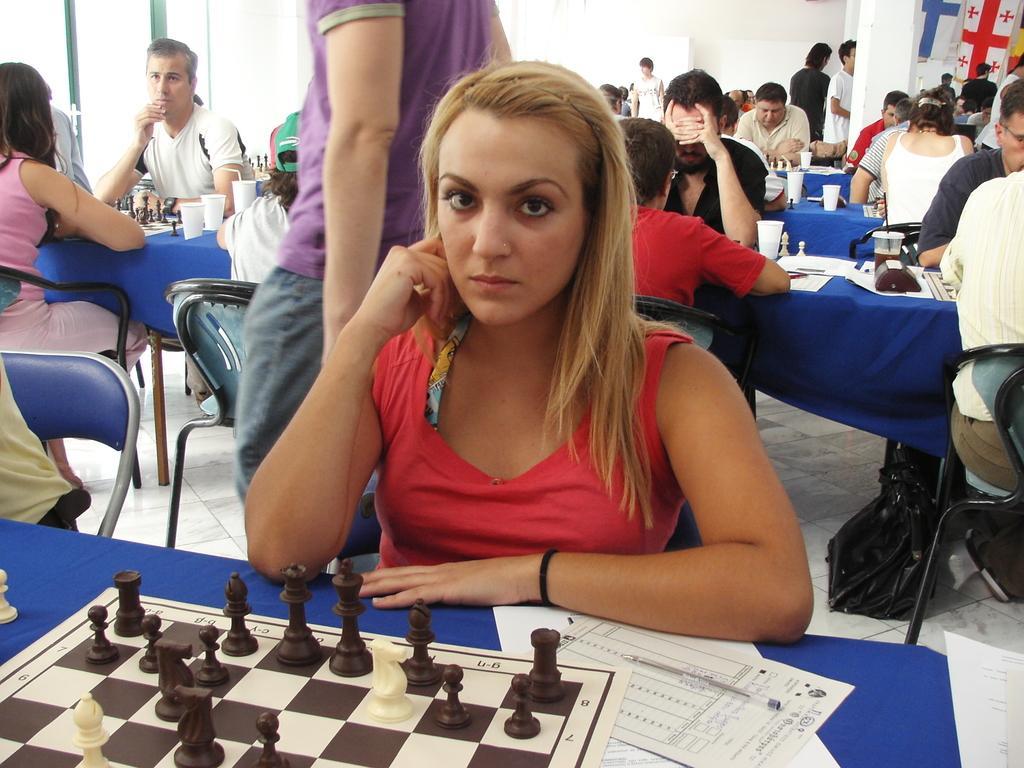Could you give a brief overview of what you see in this image? In this picture we can see a group of people where some are sitting on chairs and playing chess and some are standing and in front of them on table we have chess board, papers, pen, glass and below the tables we have bags and in background we can see wall, flags. 